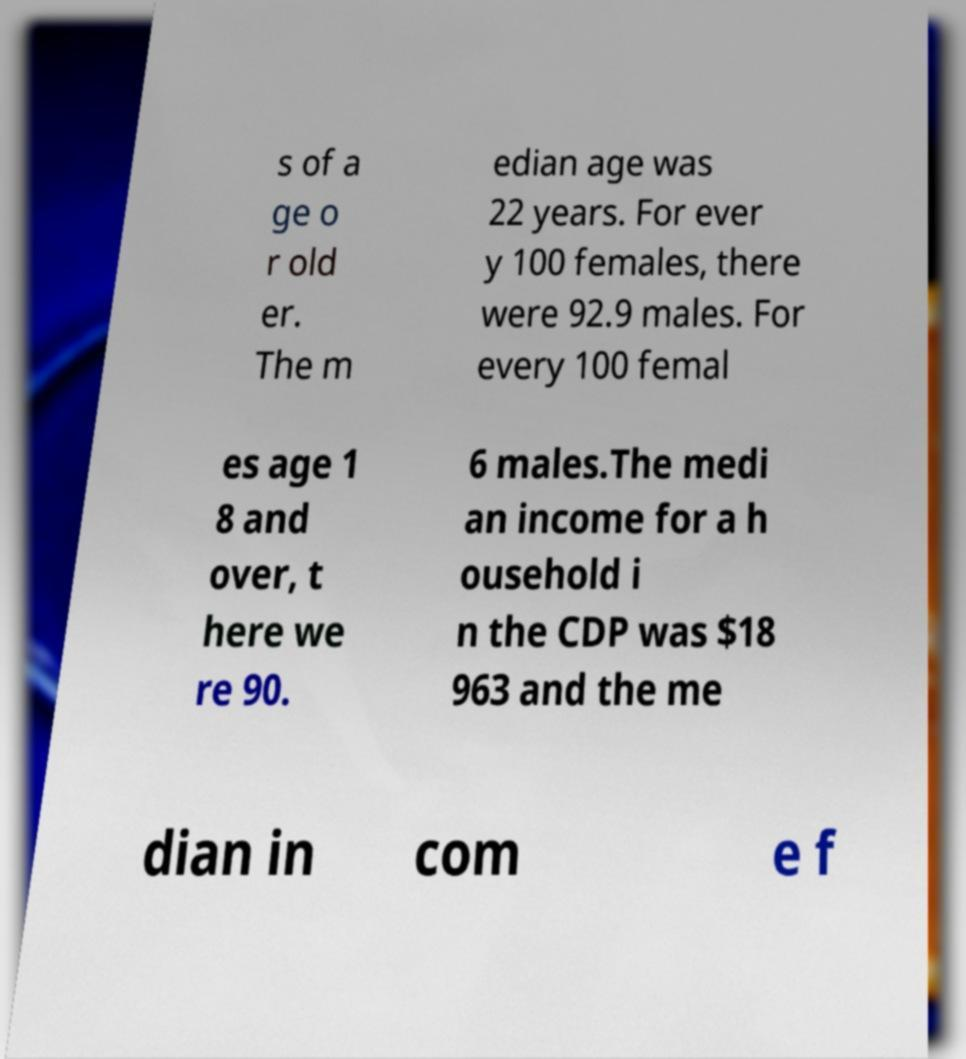Could you assist in decoding the text presented in this image and type it out clearly? s of a ge o r old er. The m edian age was 22 years. For ever y 100 females, there were 92.9 males. For every 100 femal es age 1 8 and over, t here we re 90. 6 males.The medi an income for a h ousehold i n the CDP was $18 963 and the me dian in com e f 